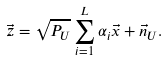<formula> <loc_0><loc_0><loc_500><loc_500>\vec { z } = \sqrt { P _ { U } } \sum _ { i = 1 } ^ { L } \alpha _ { i } \vec { x } + \vec { n } _ { U } .</formula> 